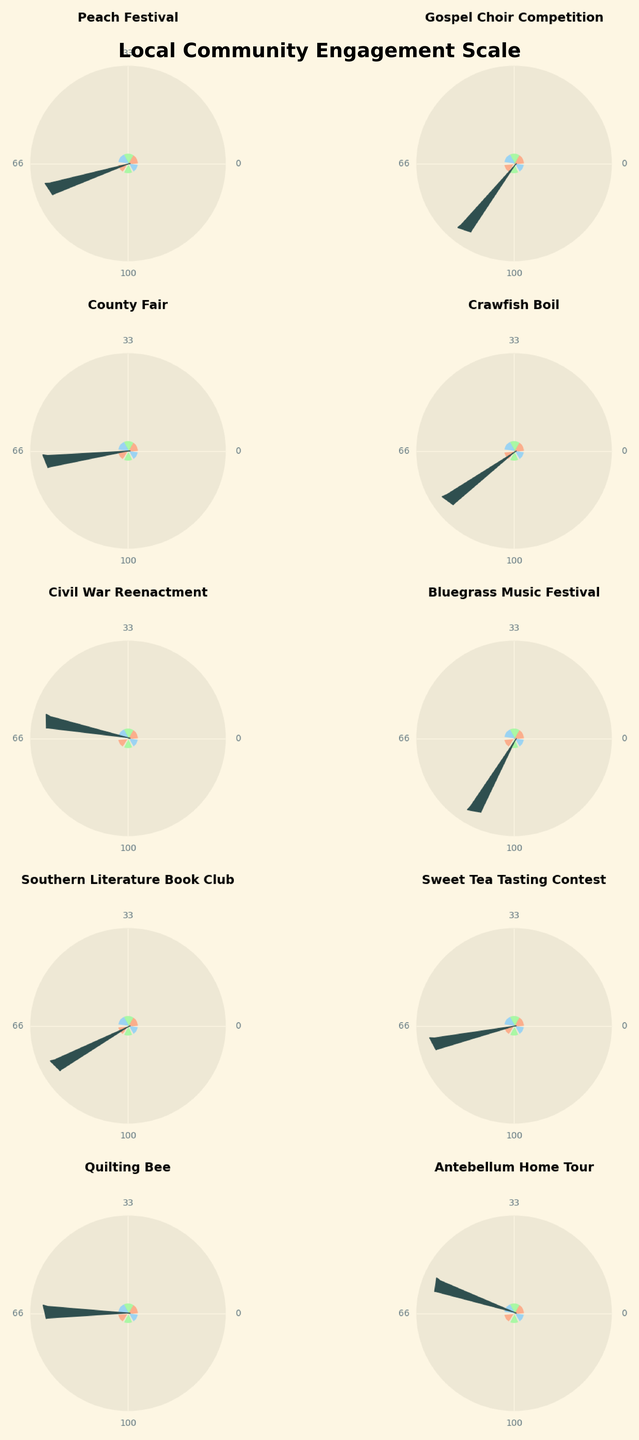Which event has the highest engagement score? The gauge chart shows different engagement scores, and the Bluegrass Music Festival has the highest score, at 88.
Answer: Bluegrass Music Festival How many events have an engagement score higher than 70? By visually checking each gauge, we find Peach Festival (72), Gospel Choir Competition (85), Crawfish Boil (79), Bluegrass Music Festival (88), and Southern Literature Book Club (76). That's five events.
Answer: 5 What is the average engagement score of all the events? The engagement scores are: 72, 85, 68, 79, 61, 88, 76, 70, 65, and 58. Adding these up equals 722. There are 10 events, so the average score is 722/10.
Answer: 72.2 Which event has the lowest engagement score? The gauge chart indicates that the Antebellum Home Tour has the lowest engagement score, at 58.
Answer: Antebellum Home Tour How much higher is the engagement score for the Bluegrass Music Festival compared to the Civil War Reenactment? The Bluegrass Music Festival's score is 88, while the Civil War Reenactment's score is 61. Subtracting these values gives us 88 - 61.
Answer: 27 Are there more events with engagement scores above 65 or below 65? Check each engagement score: above 65 includes Peach Festival, Gospel Choir Competition, Crawfish Boil, Bluegrass Music Festival, Southern Literature Book Club, and Sweet Tea Tasting Contest. Below 65 includes Quilting Bee and Antebellum Home Tour. There are more events above 65.
Answer: Above 65 What percentage of the events have an engagement score of 70 or above? There are 7 events with scores 70 or above (Peach Festival, Gospel Choir Competition, Crawfish Boil, Bluegrass Music Festival, Southern Literature Book Club, and Sweet Tea Tasting Contest). Total events are 10. Percentage = (7/10) * 100.
Answer: 70% Which two events have the closest engagement scores? Southern Literature Book Club (76) and Crawfish Boil (79) have the smallest difference, which is 3.
Answer: Southern Literature Book Club and Crawfish Boil Is the engagement score for the Gospel Choir Competition more than twice the score of the Antebellum Home Tour? The Gospel Choir Competition’s score is 85, and the Antebellum Home Tour’s score is 58. Twice 58 is 116, which is more than 85, so the answer is no.
Answer: No 